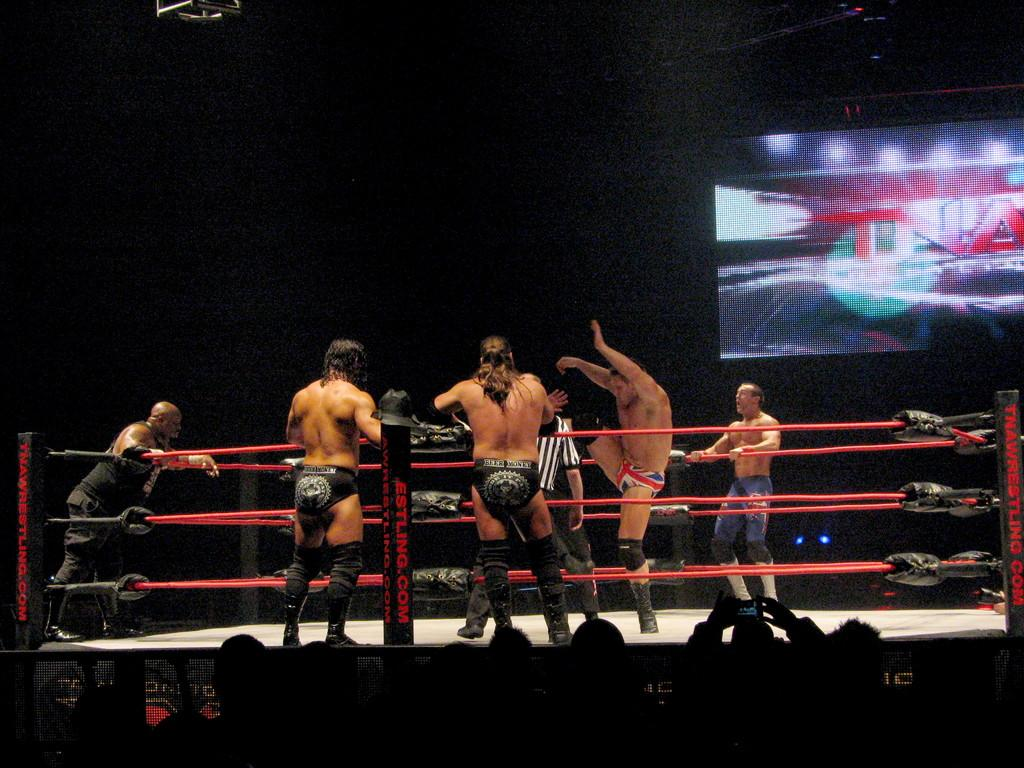<image>
Describe the image concisely. 5 wrestlers are having a match in a ring with the TNA logo visible on the screen to the right. 